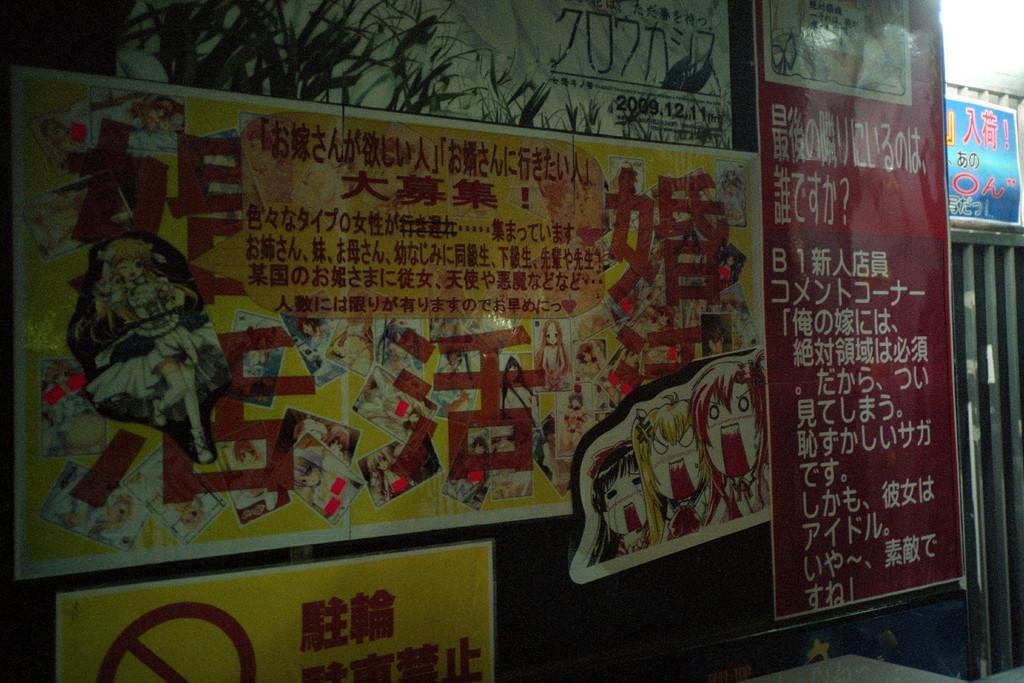In one or two sentences, can you explain what this image depicts? In this image there is a board with some images and text, beside that there is a metal structure, above the metal structure there is a banner with some text on it. 